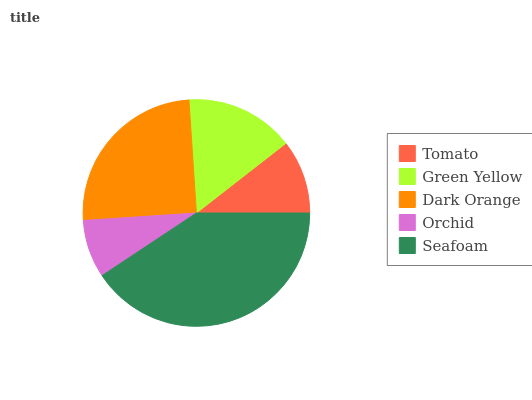Is Orchid the minimum?
Answer yes or no. Yes. Is Seafoam the maximum?
Answer yes or no. Yes. Is Green Yellow the minimum?
Answer yes or no. No. Is Green Yellow the maximum?
Answer yes or no. No. Is Green Yellow greater than Tomato?
Answer yes or no. Yes. Is Tomato less than Green Yellow?
Answer yes or no. Yes. Is Tomato greater than Green Yellow?
Answer yes or no. No. Is Green Yellow less than Tomato?
Answer yes or no. No. Is Green Yellow the high median?
Answer yes or no. Yes. Is Green Yellow the low median?
Answer yes or no. Yes. Is Seafoam the high median?
Answer yes or no. No. Is Orchid the low median?
Answer yes or no. No. 